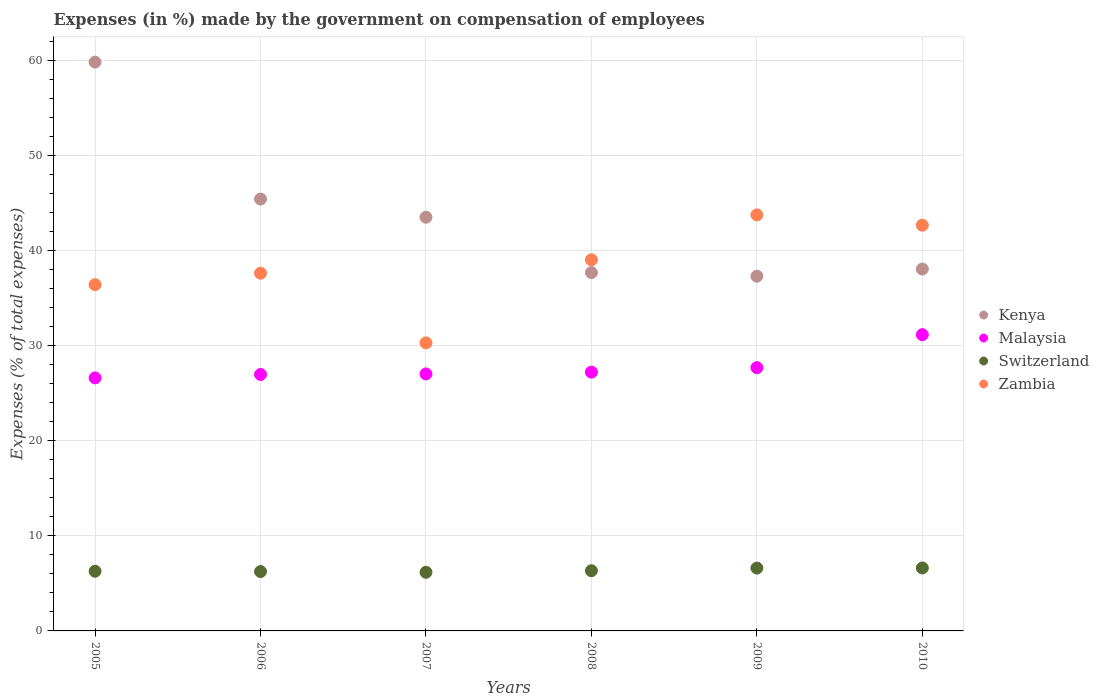Is the number of dotlines equal to the number of legend labels?
Your response must be concise. Yes. What is the percentage of expenses made by the government on compensation of employees in Kenya in 2005?
Give a very brief answer. 59.83. Across all years, what is the maximum percentage of expenses made by the government on compensation of employees in Zambia?
Your answer should be compact. 43.76. Across all years, what is the minimum percentage of expenses made by the government on compensation of employees in Zambia?
Give a very brief answer. 30.3. In which year was the percentage of expenses made by the government on compensation of employees in Kenya maximum?
Your answer should be very brief. 2005. What is the total percentage of expenses made by the government on compensation of employees in Zambia in the graph?
Keep it short and to the point. 229.82. What is the difference between the percentage of expenses made by the government on compensation of employees in Kenya in 2005 and that in 2009?
Keep it short and to the point. 22.52. What is the difference between the percentage of expenses made by the government on compensation of employees in Switzerland in 2006 and the percentage of expenses made by the government on compensation of employees in Zambia in 2007?
Make the answer very short. -24.05. What is the average percentage of expenses made by the government on compensation of employees in Malaysia per year?
Offer a terse response. 27.78. In the year 2006, what is the difference between the percentage of expenses made by the government on compensation of employees in Zambia and percentage of expenses made by the government on compensation of employees in Malaysia?
Keep it short and to the point. 10.66. In how many years, is the percentage of expenses made by the government on compensation of employees in Kenya greater than 22 %?
Ensure brevity in your answer.  6. What is the ratio of the percentage of expenses made by the government on compensation of employees in Switzerland in 2005 to that in 2009?
Offer a terse response. 0.95. Is the percentage of expenses made by the government on compensation of employees in Kenya in 2005 less than that in 2009?
Give a very brief answer. No. What is the difference between the highest and the second highest percentage of expenses made by the government on compensation of employees in Kenya?
Your answer should be compact. 14.41. What is the difference between the highest and the lowest percentage of expenses made by the government on compensation of employees in Zambia?
Offer a terse response. 13.46. In how many years, is the percentage of expenses made by the government on compensation of employees in Switzerland greater than the average percentage of expenses made by the government on compensation of employees in Switzerland taken over all years?
Provide a short and direct response. 2. Is the sum of the percentage of expenses made by the government on compensation of employees in Zambia in 2007 and 2010 greater than the maximum percentage of expenses made by the government on compensation of employees in Kenya across all years?
Ensure brevity in your answer.  Yes. Is it the case that in every year, the sum of the percentage of expenses made by the government on compensation of employees in Malaysia and percentage of expenses made by the government on compensation of employees in Switzerland  is greater than the sum of percentage of expenses made by the government on compensation of employees in Kenya and percentage of expenses made by the government on compensation of employees in Zambia?
Provide a succinct answer. No. Does the percentage of expenses made by the government on compensation of employees in Switzerland monotonically increase over the years?
Provide a succinct answer. No. Is the percentage of expenses made by the government on compensation of employees in Malaysia strictly less than the percentage of expenses made by the government on compensation of employees in Zambia over the years?
Offer a very short reply. Yes. How many years are there in the graph?
Ensure brevity in your answer.  6. Does the graph contain grids?
Ensure brevity in your answer.  Yes. What is the title of the graph?
Provide a succinct answer. Expenses (in %) made by the government on compensation of employees. What is the label or title of the X-axis?
Provide a succinct answer. Years. What is the label or title of the Y-axis?
Your response must be concise. Expenses (% of total expenses). What is the Expenses (% of total expenses) in Kenya in 2005?
Offer a very short reply. 59.83. What is the Expenses (% of total expenses) of Malaysia in 2005?
Offer a very short reply. 26.61. What is the Expenses (% of total expenses) in Switzerland in 2005?
Ensure brevity in your answer.  6.28. What is the Expenses (% of total expenses) in Zambia in 2005?
Offer a terse response. 36.42. What is the Expenses (% of total expenses) of Kenya in 2006?
Make the answer very short. 45.42. What is the Expenses (% of total expenses) of Malaysia in 2006?
Provide a short and direct response. 26.97. What is the Expenses (% of total expenses) in Switzerland in 2006?
Provide a succinct answer. 6.24. What is the Expenses (% of total expenses) in Zambia in 2006?
Give a very brief answer. 37.63. What is the Expenses (% of total expenses) of Kenya in 2007?
Provide a succinct answer. 43.51. What is the Expenses (% of total expenses) of Malaysia in 2007?
Your answer should be compact. 27.03. What is the Expenses (% of total expenses) in Switzerland in 2007?
Make the answer very short. 6.17. What is the Expenses (% of total expenses) in Zambia in 2007?
Give a very brief answer. 30.3. What is the Expenses (% of total expenses) in Kenya in 2008?
Your answer should be very brief. 37.69. What is the Expenses (% of total expenses) of Malaysia in 2008?
Provide a succinct answer. 27.22. What is the Expenses (% of total expenses) in Switzerland in 2008?
Keep it short and to the point. 6.33. What is the Expenses (% of total expenses) in Zambia in 2008?
Ensure brevity in your answer.  39.03. What is the Expenses (% of total expenses) in Kenya in 2009?
Offer a very short reply. 37.31. What is the Expenses (% of total expenses) of Malaysia in 2009?
Ensure brevity in your answer.  27.69. What is the Expenses (% of total expenses) of Switzerland in 2009?
Offer a terse response. 6.61. What is the Expenses (% of total expenses) in Zambia in 2009?
Keep it short and to the point. 43.76. What is the Expenses (% of total expenses) in Kenya in 2010?
Your answer should be compact. 38.07. What is the Expenses (% of total expenses) of Malaysia in 2010?
Provide a short and direct response. 31.16. What is the Expenses (% of total expenses) of Switzerland in 2010?
Your answer should be compact. 6.62. What is the Expenses (% of total expenses) of Zambia in 2010?
Provide a succinct answer. 42.68. Across all years, what is the maximum Expenses (% of total expenses) in Kenya?
Make the answer very short. 59.83. Across all years, what is the maximum Expenses (% of total expenses) of Malaysia?
Provide a short and direct response. 31.16. Across all years, what is the maximum Expenses (% of total expenses) of Switzerland?
Provide a short and direct response. 6.62. Across all years, what is the maximum Expenses (% of total expenses) in Zambia?
Provide a short and direct response. 43.76. Across all years, what is the minimum Expenses (% of total expenses) of Kenya?
Give a very brief answer. 37.31. Across all years, what is the minimum Expenses (% of total expenses) of Malaysia?
Make the answer very short. 26.61. Across all years, what is the minimum Expenses (% of total expenses) of Switzerland?
Offer a very short reply. 6.17. Across all years, what is the minimum Expenses (% of total expenses) in Zambia?
Provide a short and direct response. 30.3. What is the total Expenses (% of total expenses) in Kenya in the graph?
Keep it short and to the point. 261.83. What is the total Expenses (% of total expenses) of Malaysia in the graph?
Offer a very short reply. 166.69. What is the total Expenses (% of total expenses) in Switzerland in the graph?
Your response must be concise. 38.25. What is the total Expenses (% of total expenses) of Zambia in the graph?
Provide a short and direct response. 229.82. What is the difference between the Expenses (% of total expenses) in Kenya in 2005 and that in 2006?
Ensure brevity in your answer.  14.41. What is the difference between the Expenses (% of total expenses) of Malaysia in 2005 and that in 2006?
Your answer should be very brief. -0.36. What is the difference between the Expenses (% of total expenses) of Switzerland in 2005 and that in 2006?
Provide a short and direct response. 0.03. What is the difference between the Expenses (% of total expenses) in Zambia in 2005 and that in 2006?
Ensure brevity in your answer.  -1.21. What is the difference between the Expenses (% of total expenses) of Kenya in 2005 and that in 2007?
Your answer should be compact. 16.32. What is the difference between the Expenses (% of total expenses) in Malaysia in 2005 and that in 2007?
Offer a very short reply. -0.42. What is the difference between the Expenses (% of total expenses) of Switzerland in 2005 and that in 2007?
Offer a very short reply. 0.11. What is the difference between the Expenses (% of total expenses) of Zambia in 2005 and that in 2007?
Provide a short and direct response. 6.12. What is the difference between the Expenses (% of total expenses) in Kenya in 2005 and that in 2008?
Provide a succinct answer. 22.14. What is the difference between the Expenses (% of total expenses) of Malaysia in 2005 and that in 2008?
Provide a short and direct response. -0.61. What is the difference between the Expenses (% of total expenses) in Switzerland in 2005 and that in 2008?
Offer a very short reply. -0.05. What is the difference between the Expenses (% of total expenses) of Zambia in 2005 and that in 2008?
Give a very brief answer. -2.62. What is the difference between the Expenses (% of total expenses) in Kenya in 2005 and that in 2009?
Keep it short and to the point. 22.52. What is the difference between the Expenses (% of total expenses) in Malaysia in 2005 and that in 2009?
Offer a very short reply. -1.08. What is the difference between the Expenses (% of total expenses) of Switzerland in 2005 and that in 2009?
Your response must be concise. -0.33. What is the difference between the Expenses (% of total expenses) of Zambia in 2005 and that in 2009?
Give a very brief answer. -7.34. What is the difference between the Expenses (% of total expenses) in Kenya in 2005 and that in 2010?
Ensure brevity in your answer.  21.77. What is the difference between the Expenses (% of total expenses) in Malaysia in 2005 and that in 2010?
Provide a succinct answer. -4.54. What is the difference between the Expenses (% of total expenses) of Switzerland in 2005 and that in 2010?
Give a very brief answer. -0.34. What is the difference between the Expenses (% of total expenses) of Zambia in 2005 and that in 2010?
Your answer should be compact. -6.26. What is the difference between the Expenses (% of total expenses) of Kenya in 2006 and that in 2007?
Offer a terse response. 1.91. What is the difference between the Expenses (% of total expenses) of Malaysia in 2006 and that in 2007?
Offer a very short reply. -0.06. What is the difference between the Expenses (% of total expenses) in Switzerland in 2006 and that in 2007?
Your response must be concise. 0.08. What is the difference between the Expenses (% of total expenses) of Zambia in 2006 and that in 2007?
Your answer should be very brief. 7.33. What is the difference between the Expenses (% of total expenses) in Kenya in 2006 and that in 2008?
Make the answer very short. 7.73. What is the difference between the Expenses (% of total expenses) in Malaysia in 2006 and that in 2008?
Make the answer very short. -0.25. What is the difference between the Expenses (% of total expenses) of Switzerland in 2006 and that in 2008?
Provide a short and direct response. -0.09. What is the difference between the Expenses (% of total expenses) of Zambia in 2006 and that in 2008?
Give a very brief answer. -1.41. What is the difference between the Expenses (% of total expenses) in Kenya in 2006 and that in 2009?
Make the answer very short. 8.11. What is the difference between the Expenses (% of total expenses) of Malaysia in 2006 and that in 2009?
Your answer should be compact. -0.72. What is the difference between the Expenses (% of total expenses) of Switzerland in 2006 and that in 2009?
Ensure brevity in your answer.  -0.36. What is the difference between the Expenses (% of total expenses) in Zambia in 2006 and that in 2009?
Ensure brevity in your answer.  -6.13. What is the difference between the Expenses (% of total expenses) of Kenya in 2006 and that in 2010?
Your response must be concise. 7.36. What is the difference between the Expenses (% of total expenses) in Malaysia in 2006 and that in 2010?
Ensure brevity in your answer.  -4.19. What is the difference between the Expenses (% of total expenses) of Switzerland in 2006 and that in 2010?
Your answer should be very brief. -0.38. What is the difference between the Expenses (% of total expenses) of Zambia in 2006 and that in 2010?
Give a very brief answer. -5.05. What is the difference between the Expenses (% of total expenses) in Kenya in 2007 and that in 2008?
Ensure brevity in your answer.  5.82. What is the difference between the Expenses (% of total expenses) in Malaysia in 2007 and that in 2008?
Offer a very short reply. -0.19. What is the difference between the Expenses (% of total expenses) of Switzerland in 2007 and that in 2008?
Offer a very short reply. -0.16. What is the difference between the Expenses (% of total expenses) of Zambia in 2007 and that in 2008?
Offer a very short reply. -8.74. What is the difference between the Expenses (% of total expenses) in Kenya in 2007 and that in 2009?
Ensure brevity in your answer.  6.2. What is the difference between the Expenses (% of total expenses) of Malaysia in 2007 and that in 2009?
Ensure brevity in your answer.  -0.66. What is the difference between the Expenses (% of total expenses) of Switzerland in 2007 and that in 2009?
Keep it short and to the point. -0.44. What is the difference between the Expenses (% of total expenses) in Zambia in 2007 and that in 2009?
Your answer should be compact. -13.46. What is the difference between the Expenses (% of total expenses) of Kenya in 2007 and that in 2010?
Your answer should be compact. 5.45. What is the difference between the Expenses (% of total expenses) in Malaysia in 2007 and that in 2010?
Your answer should be very brief. -4.13. What is the difference between the Expenses (% of total expenses) of Switzerland in 2007 and that in 2010?
Provide a succinct answer. -0.46. What is the difference between the Expenses (% of total expenses) of Zambia in 2007 and that in 2010?
Your answer should be compact. -12.38. What is the difference between the Expenses (% of total expenses) of Kenya in 2008 and that in 2009?
Ensure brevity in your answer.  0.38. What is the difference between the Expenses (% of total expenses) in Malaysia in 2008 and that in 2009?
Make the answer very short. -0.47. What is the difference between the Expenses (% of total expenses) of Switzerland in 2008 and that in 2009?
Make the answer very short. -0.28. What is the difference between the Expenses (% of total expenses) in Zambia in 2008 and that in 2009?
Provide a short and direct response. -4.73. What is the difference between the Expenses (% of total expenses) in Kenya in 2008 and that in 2010?
Offer a very short reply. -0.38. What is the difference between the Expenses (% of total expenses) of Malaysia in 2008 and that in 2010?
Provide a short and direct response. -3.94. What is the difference between the Expenses (% of total expenses) in Switzerland in 2008 and that in 2010?
Provide a succinct answer. -0.29. What is the difference between the Expenses (% of total expenses) in Zambia in 2008 and that in 2010?
Make the answer very short. -3.64. What is the difference between the Expenses (% of total expenses) of Kenya in 2009 and that in 2010?
Ensure brevity in your answer.  -0.76. What is the difference between the Expenses (% of total expenses) of Malaysia in 2009 and that in 2010?
Offer a terse response. -3.47. What is the difference between the Expenses (% of total expenses) of Switzerland in 2009 and that in 2010?
Offer a very short reply. -0.01. What is the difference between the Expenses (% of total expenses) of Zambia in 2009 and that in 2010?
Provide a short and direct response. 1.08. What is the difference between the Expenses (% of total expenses) in Kenya in 2005 and the Expenses (% of total expenses) in Malaysia in 2006?
Your response must be concise. 32.86. What is the difference between the Expenses (% of total expenses) of Kenya in 2005 and the Expenses (% of total expenses) of Switzerland in 2006?
Ensure brevity in your answer.  53.59. What is the difference between the Expenses (% of total expenses) of Kenya in 2005 and the Expenses (% of total expenses) of Zambia in 2006?
Give a very brief answer. 22.2. What is the difference between the Expenses (% of total expenses) in Malaysia in 2005 and the Expenses (% of total expenses) in Switzerland in 2006?
Provide a short and direct response. 20.37. What is the difference between the Expenses (% of total expenses) in Malaysia in 2005 and the Expenses (% of total expenses) in Zambia in 2006?
Your answer should be compact. -11.01. What is the difference between the Expenses (% of total expenses) of Switzerland in 2005 and the Expenses (% of total expenses) of Zambia in 2006?
Make the answer very short. -31.35. What is the difference between the Expenses (% of total expenses) in Kenya in 2005 and the Expenses (% of total expenses) in Malaysia in 2007?
Keep it short and to the point. 32.8. What is the difference between the Expenses (% of total expenses) of Kenya in 2005 and the Expenses (% of total expenses) of Switzerland in 2007?
Provide a short and direct response. 53.66. What is the difference between the Expenses (% of total expenses) of Kenya in 2005 and the Expenses (% of total expenses) of Zambia in 2007?
Offer a very short reply. 29.53. What is the difference between the Expenses (% of total expenses) of Malaysia in 2005 and the Expenses (% of total expenses) of Switzerland in 2007?
Offer a terse response. 20.45. What is the difference between the Expenses (% of total expenses) of Malaysia in 2005 and the Expenses (% of total expenses) of Zambia in 2007?
Give a very brief answer. -3.68. What is the difference between the Expenses (% of total expenses) of Switzerland in 2005 and the Expenses (% of total expenses) of Zambia in 2007?
Offer a terse response. -24.02. What is the difference between the Expenses (% of total expenses) of Kenya in 2005 and the Expenses (% of total expenses) of Malaysia in 2008?
Ensure brevity in your answer.  32.61. What is the difference between the Expenses (% of total expenses) of Kenya in 2005 and the Expenses (% of total expenses) of Switzerland in 2008?
Make the answer very short. 53.5. What is the difference between the Expenses (% of total expenses) in Kenya in 2005 and the Expenses (% of total expenses) in Zambia in 2008?
Offer a terse response. 20.8. What is the difference between the Expenses (% of total expenses) in Malaysia in 2005 and the Expenses (% of total expenses) in Switzerland in 2008?
Offer a terse response. 20.28. What is the difference between the Expenses (% of total expenses) of Malaysia in 2005 and the Expenses (% of total expenses) of Zambia in 2008?
Offer a terse response. -12.42. What is the difference between the Expenses (% of total expenses) in Switzerland in 2005 and the Expenses (% of total expenses) in Zambia in 2008?
Keep it short and to the point. -32.76. What is the difference between the Expenses (% of total expenses) of Kenya in 2005 and the Expenses (% of total expenses) of Malaysia in 2009?
Your response must be concise. 32.14. What is the difference between the Expenses (% of total expenses) in Kenya in 2005 and the Expenses (% of total expenses) in Switzerland in 2009?
Your response must be concise. 53.22. What is the difference between the Expenses (% of total expenses) in Kenya in 2005 and the Expenses (% of total expenses) in Zambia in 2009?
Give a very brief answer. 16.07. What is the difference between the Expenses (% of total expenses) of Malaysia in 2005 and the Expenses (% of total expenses) of Switzerland in 2009?
Your response must be concise. 20. What is the difference between the Expenses (% of total expenses) of Malaysia in 2005 and the Expenses (% of total expenses) of Zambia in 2009?
Provide a succinct answer. -17.15. What is the difference between the Expenses (% of total expenses) in Switzerland in 2005 and the Expenses (% of total expenses) in Zambia in 2009?
Your answer should be compact. -37.48. What is the difference between the Expenses (% of total expenses) of Kenya in 2005 and the Expenses (% of total expenses) of Malaysia in 2010?
Provide a succinct answer. 28.67. What is the difference between the Expenses (% of total expenses) of Kenya in 2005 and the Expenses (% of total expenses) of Switzerland in 2010?
Your answer should be very brief. 53.21. What is the difference between the Expenses (% of total expenses) of Kenya in 2005 and the Expenses (% of total expenses) of Zambia in 2010?
Keep it short and to the point. 17.16. What is the difference between the Expenses (% of total expenses) of Malaysia in 2005 and the Expenses (% of total expenses) of Switzerland in 2010?
Provide a succinct answer. 19.99. What is the difference between the Expenses (% of total expenses) of Malaysia in 2005 and the Expenses (% of total expenses) of Zambia in 2010?
Offer a terse response. -16.06. What is the difference between the Expenses (% of total expenses) in Switzerland in 2005 and the Expenses (% of total expenses) in Zambia in 2010?
Keep it short and to the point. -36.4. What is the difference between the Expenses (% of total expenses) in Kenya in 2006 and the Expenses (% of total expenses) in Malaysia in 2007?
Offer a very short reply. 18.39. What is the difference between the Expenses (% of total expenses) of Kenya in 2006 and the Expenses (% of total expenses) of Switzerland in 2007?
Keep it short and to the point. 39.26. What is the difference between the Expenses (% of total expenses) of Kenya in 2006 and the Expenses (% of total expenses) of Zambia in 2007?
Ensure brevity in your answer.  15.12. What is the difference between the Expenses (% of total expenses) in Malaysia in 2006 and the Expenses (% of total expenses) in Switzerland in 2007?
Make the answer very short. 20.81. What is the difference between the Expenses (% of total expenses) in Malaysia in 2006 and the Expenses (% of total expenses) in Zambia in 2007?
Keep it short and to the point. -3.33. What is the difference between the Expenses (% of total expenses) of Switzerland in 2006 and the Expenses (% of total expenses) of Zambia in 2007?
Keep it short and to the point. -24.05. What is the difference between the Expenses (% of total expenses) of Kenya in 2006 and the Expenses (% of total expenses) of Malaysia in 2008?
Offer a very short reply. 18.2. What is the difference between the Expenses (% of total expenses) of Kenya in 2006 and the Expenses (% of total expenses) of Switzerland in 2008?
Make the answer very short. 39.09. What is the difference between the Expenses (% of total expenses) in Kenya in 2006 and the Expenses (% of total expenses) in Zambia in 2008?
Provide a short and direct response. 6.39. What is the difference between the Expenses (% of total expenses) in Malaysia in 2006 and the Expenses (% of total expenses) in Switzerland in 2008?
Provide a short and direct response. 20.64. What is the difference between the Expenses (% of total expenses) in Malaysia in 2006 and the Expenses (% of total expenses) in Zambia in 2008?
Keep it short and to the point. -12.06. What is the difference between the Expenses (% of total expenses) in Switzerland in 2006 and the Expenses (% of total expenses) in Zambia in 2008?
Keep it short and to the point. -32.79. What is the difference between the Expenses (% of total expenses) of Kenya in 2006 and the Expenses (% of total expenses) of Malaysia in 2009?
Provide a succinct answer. 17.73. What is the difference between the Expenses (% of total expenses) in Kenya in 2006 and the Expenses (% of total expenses) in Switzerland in 2009?
Offer a very short reply. 38.81. What is the difference between the Expenses (% of total expenses) of Kenya in 2006 and the Expenses (% of total expenses) of Zambia in 2009?
Make the answer very short. 1.66. What is the difference between the Expenses (% of total expenses) in Malaysia in 2006 and the Expenses (% of total expenses) in Switzerland in 2009?
Your response must be concise. 20.36. What is the difference between the Expenses (% of total expenses) of Malaysia in 2006 and the Expenses (% of total expenses) of Zambia in 2009?
Provide a succinct answer. -16.79. What is the difference between the Expenses (% of total expenses) in Switzerland in 2006 and the Expenses (% of total expenses) in Zambia in 2009?
Provide a short and direct response. -37.52. What is the difference between the Expenses (% of total expenses) of Kenya in 2006 and the Expenses (% of total expenses) of Malaysia in 2010?
Offer a terse response. 14.27. What is the difference between the Expenses (% of total expenses) in Kenya in 2006 and the Expenses (% of total expenses) in Switzerland in 2010?
Your answer should be compact. 38.8. What is the difference between the Expenses (% of total expenses) of Kenya in 2006 and the Expenses (% of total expenses) of Zambia in 2010?
Offer a very short reply. 2.75. What is the difference between the Expenses (% of total expenses) in Malaysia in 2006 and the Expenses (% of total expenses) in Switzerland in 2010?
Your response must be concise. 20.35. What is the difference between the Expenses (% of total expenses) of Malaysia in 2006 and the Expenses (% of total expenses) of Zambia in 2010?
Your answer should be compact. -15.7. What is the difference between the Expenses (% of total expenses) of Switzerland in 2006 and the Expenses (% of total expenses) of Zambia in 2010?
Ensure brevity in your answer.  -36.43. What is the difference between the Expenses (% of total expenses) in Kenya in 2007 and the Expenses (% of total expenses) in Malaysia in 2008?
Your answer should be very brief. 16.29. What is the difference between the Expenses (% of total expenses) of Kenya in 2007 and the Expenses (% of total expenses) of Switzerland in 2008?
Provide a short and direct response. 37.18. What is the difference between the Expenses (% of total expenses) in Kenya in 2007 and the Expenses (% of total expenses) in Zambia in 2008?
Ensure brevity in your answer.  4.48. What is the difference between the Expenses (% of total expenses) of Malaysia in 2007 and the Expenses (% of total expenses) of Switzerland in 2008?
Offer a terse response. 20.7. What is the difference between the Expenses (% of total expenses) of Malaysia in 2007 and the Expenses (% of total expenses) of Zambia in 2008?
Your response must be concise. -12. What is the difference between the Expenses (% of total expenses) of Switzerland in 2007 and the Expenses (% of total expenses) of Zambia in 2008?
Your response must be concise. -32.87. What is the difference between the Expenses (% of total expenses) in Kenya in 2007 and the Expenses (% of total expenses) in Malaysia in 2009?
Your answer should be very brief. 15.82. What is the difference between the Expenses (% of total expenses) in Kenya in 2007 and the Expenses (% of total expenses) in Switzerland in 2009?
Offer a terse response. 36.9. What is the difference between the Expenses (% of total expenses) in Kenya in 2007 and the Expenses (% of total expenses) in Zambia in 2009?
Your answer should be very brief. -0.25. What is the difference between the Expenses (% of total expenses) of Malaysia in 2007 and the Expenses (% of total expenses) of Switzerland in 2009?
Your response must be concise. 20.42. What is the difference between the Expenses (% of total expenses) of Malaysia in 2007 and the Expenses (% of total expenses) of Zambia in 2009?
Make the answer very short. -16.73. What is the difference between the Expenses (% of total expenses) in Switzerland in 2007 and the Expenses (% of total expenses) in Zambia in 2009?
Your answer should be very brief. -37.59. What is the difference between the Expenses (% of total expenses) in Kenya in 2007 and the Expenses (% of total expenses) in Malaysia in 2010?
Make the answer very short. 12.35. What is the difference between the Expenses (% of total expenses) of Kenya in 2007 and the Expenses (% of total expenses) of Switzerland in 2010?
Give a very brief answer. 36.89. What is the difference between the Expenses (% of total expenses) in Kenya in 2007 and the Expenses (% of total expenses) in Zambia in 2010?
Your answer should be compact. 0.84. What is the difference between the Expenses (% of total expenses) in Malaysia in 2007 and the Expenses (% of total expenses) in Switzerland in 2010?
Provide a succinct answer. 20.41. What is the difference between the Expenses (% of total expenses) in Malaysia in 2007 and the Expenses (% of total expenses) in Zambia in 2010?
Give a very brief answer. -15.64. What is the difference between the Expenses (% of total expenses) in Switzerland in 2007 and the Expenses (% of total expenses) in Zambia in 2010?
Your answer should be compact. -36.51. What is the difference between the Expenses (% of total expenses) in Kenya in 2008 and the Expenses (% of total expenses) in Malaysia in 2009?
Make the answer very short. 10. What is the difference between the Expenses (% of total expenses) of Kenya in 2008 and the Expenses (% of total expenses) of Switzerland in 2009?
Your response must be concise. 31.08. What is the difference between the Expenses (% of total expenses) in Kenya in 2008 and the Expenses (% of total expenses) in Zambia in 2009?
Ensure brevity in your answer.  -6.07. What is the difference between the Expenses (% of total expenses) of Malaysia in 2008 and the Expenses (% of total expenses) of Switzerland in 2009?
Ensure brevity in your answer.  20.61. What is the difference between the Expenses (% of total expenses) of Malaysia in 2008 and the Expenses (% of total expenses) of Zambia in 2009?
Your answer should be very brief. -16.54. What is the difference between the Expenses (% of total expenses) of Switzerland in 2008 and the Expenses (% of total expenses) of Zambia in 2009?
Ensure brevity in your answer.  -37.43. What is the difference between the Expenses (% of total expenses) in Kenya in 2008 and the Expenses (% of total expenses) in Malaysia in 2010?
Ensure brevity in your answer.  6.53. What is the difference between the Expenses (% of total expenses) in Kenya in 2008 and the Expenses (% of total expenses) in Switzerland in 2010?
Provide a succinct answer. 31.07. What is the difference between the Expenses (% of total expenses) in Kenya in 2008 and the Expenses (% of total expenses) in Zambia in 2010?
Offer a very short reply. -4.99. What is the difference between the Expenses (% of total expenses) in Malaysia in 2008 and the Expenses (% of total expenses) in Switzerland in 2010?
Make the answer very short. 20.6. What is the difference between the Expenses (% of total expenses) in Malaysia in 2008 and the Expenses (% of total expenses) in Zambia in 2010?
Your response must be concise. -15.46. What is the difference between the Expenses (% of total expenses) of Switzerland in 2008 and the Expenses (% of total expenses) of Zambia in 2010?
Keep it short and to the point. -36.35. What is the difference between the Expenses (% of total expenses) of Kenya in 2009 and the Expenses (% of total expenses) of Malaysia in 2010?
Provide a succinct answer. 6.15. What is the difference between the Expenses (% of total expenses) of Kenya in 2009 and the Expenses (% of total expenses) of Switzerland in 2010?
Give a very brief answer. 30.69. What is the difference between the Expenses (% of total expenses) of Kenya in 2009 and the Expenses (% of total expenses) of Zambia in 2010?
Your response must be concise. -5.37. What is the difference between the Expenses (% of total expenses) of Malaysia in 2009 and the Expenses (% of total expenses) of Switzerland in 2010?
Ensure brevity in your answer.  21.07. What is the difference between the Expenses (% of total expenses) in Malaysia in 2009 and the Expenses (% of total expenses) in Zambia in 2010?
Provide a succinct answer. -14.99. What is the difference between the Expenses (% of total expenses) of Switzerland in 2009 and the Expenses (% of total expenses) of Zambia in 2010?
Provide a short and direct response. -36.07. What is the average Expenses (% of total expenses) in Kenya per year?
Give a very brief answer. 43.64. What is the average Expenses (% of total expenses) of Malaysia per year?
Ensure brevity in your answer.  27.78. What is the average Expenses (% of total expenses) of Switzerland per year?
Provide a succinct answer. 6.38. What is the average Expenses (% of total expenses) in Zambia per year?
Your answer should be very brief. 38.3. In the year 2005, what is the difference between the Expenses (% of total expenses) of Kenya and Expenses (% of total expenses) of Malaysia?
Keep it short and to the point. 33.22. In the year 2005, what is the difference between the Expenses (% of total expenses) in Kenya and Expenses (% of total expenses) in Switzerland?
Offer a terse response. 53.55. In the year 2005, what is the difference between the Expenses (% of total expenses) of Kenya and Expenses (% of total expenses) of Zambia?
Provide a succinct answer. 23.41. In the year 2005, what is the difference between the Expenses (% of total expenses) in Malaysia and Expenses (% of total expenses) in Switzerland?
Offer a very short reply. 20.34. In the year 2005, what is the difference between the Expenses (% of total expenses) in Malaysia and Expenses (% of total expenses) in Zambia?
Offer a very short reply. -9.8. In the year 2005, what is the difference between the Expenses (% of total expenses) in Switzerland and Expenses (% of total expenses) in Zambia?
Your response must be concise. -30.14. In the year 2006, what is the difference between the Expenses (% of total expenses) in Kenya and Expenses (% of total expenses) in Malaysia?
Your answer should be very brief. 18.45. In the year 2006, what is the difference between the Expenses (% of total expenses) in Kenya and Expenses (% of total expenses) in Switzerland?
Provide a succinct answer. 39.18. In the year 2006, what is the difference between the Expenses (% of total expenses) of Kenya and Expenses (% of total expenses) of Zambia?
Your answer should be compact. 7.79. In the year 2006, what is the difference between the Expenses (% of total expenses) in Malaysia and Expenses (% of total expenses) in Switzerland?
Offer a very short reply. 20.73. In the year 2006, what is the difference between the Expenses (% of total expenses) of Malaysia and Expenses (% of total expenses) of Zambia?
Your response must be concise. -10.66. In the year 2006, what is the difference between the Expenses (% of total expenses) in Switzerland and Expenses (% of total expenses) in Zambia?
Your answer should be very brief. -31.38. In the year 2007, what is the difference between the Expenses (% of total expenses) in Kenya and Expenses (% of total expenses) in Malaysia?
Ensure brevity in your answer.  16.48. In the year 2007, what is the difference between the Expenses (% of total expenses) of Kenya and Expenses (% of total expenses) of Switzerland?
Offer a terse response. 37.34. In the year 2007, what is the difference between the Expenses (% of total expenses) of Kenya and Expenses (% of total expenses) of Zambia?
Provide a short and direct response. 13.21. In the year 2007, what is the difference between the Expenses (% of total expenses) in Malaysia and Expenses (% of total expenses) in Switzerland?
Offer a very short reply. 20.87. In the year 2007, what is the difference between the Expenses (% of total expenses) of Malaysia and Expenses (% of total expenses) of Zambia?
Offer a very short reply. -3.27. In the year 2007, what is the difference between the Expenses (% of total expenses) of Switzerland and Expenses (% of total expenses) of Zambia?
Your response must be concise. -24.13. In the year 2008, what is the difference between the Expenses (% of total expenses) in Kenya and Expenses (% of total expenses) in Malaysia?
Provide a succinct answer. 10.47. In the year 2008, what is the difference between the Expenses (% of total expenses) in Kenya and Expenses (% of total expenses) in Switzerland?
Make the answer very short. 31.36. In the year 2008, what is the difference between the Expenses (% of total expenses) of Kenya and Expenses (% of total expenses) of Zambia?
Provide a short and direct response. -1.35. In the year 2008, what is the difference between the Expenses (% of total expenses) of Malaysia and Expenses (% of total expenses) of Switzerland?
Give a very brief answer. 20.89. In the year 2008, what is the difference between the Expenses (% of total expenses) in Malaysia and Expenses (% of total expenses) in Zambia?
Ensure brevity in your answer.  -11.81. In the year 2008, what is the difference between the Expenses (% of total expenses) of Switzerland and Expenses (% of total expenses) of Zambia?
Give a very brief answer. -32.7. In the year 2009, what is the difference between the Expenses (% of total expenses) of Kenya and Expenses (% of total expenses) of Malaysia?
Give a very brief answer. 9.62. In the year 2009, what is the difference between the Expenses (% of total expenses) in Kenya and Expenses (% of total expenses) in Switzerland?
Offer a terse response. 30.7. In the year 2009, what is the difference between the Expenses (% of total expenses) of Kenya and Expenses (% of total expenses) of Zambia?
Keep it short and to the point. -6.45. In the year 2009, what is the difference between the Expenses (% of total expenses) in Malaysia and Expenses (% of total expenses) in Switzerland?
Make the answer very short. 21.08. In the year 2009, what is the difference between the Expenses (% of total expenses) of Malaysia and Expenses (% of total expenses) of Zambia?
Your answer should be very brief. -16.07. In the year 2009, what is the difference between the Expenses (% of total expenses) in Switzerland and Expenses (% of total expenses) in Zambia?
Your answer should be very brief. -37.15. In the year 2010, what is the difference between the Expenses (% of total expenses) in Kenya and Expenses (% of total expenses) in Malaysia?
Provide a short and direct response. 6.91. In the year 2010, what is the difference between the Expenses (% of total expenses) of Kenya and Expenses (% of total expenses) of Switzerland?
Offer a terse response. 31.44. In the year 2010, what is the difference between the Expenses (% of total expenses) in Kenya and Expenses (% of total expenses) in Zambia?
Your response must be concise. -4.61. In the year 2010, what is the difference between the Expenses (% of total expenses) of Malaysia and Expenses (% of total expenses) of Switzerland?
Your answer should be compact. 24.53. In the year 2010, what is the difference between the Expenses (% of total expenses) in Malaysia and Expenses (% of total expenses) in Zambia?
Offer a terse response. -11.52. In the year 2010, what is the difference between the Expenses (% of total expenses) in Switzerland and Expenses (% of total expenses) in Zambia?
Provide a short and direct response. -36.05. What is the ratio of the Expenses (% of total expenses) of Kenya in 2005 to that in 2006?
Offer a very short reply. 1.32. What is the ratio of the Expenses (% of total expenses) in Malaysia in 2005 to that in 2006?
Ensure brevity in your answer.  0.99. What is the ratio of the Expenses (% of total expenses) of Switzerland in 2005 to that in 2006?
Give a very brief answer. 1.01. What is the ratio of the Expenses (% of total expenses) in Zambia in 2005 to that in 2006?
Your answer should be very brief. 0.97. What is the ratio of the Expenses (% of total expenses) in Kenya in 2005 to that in 2007?
Provide a short and direct response. 1.38. What is the ratio of the Expenses (% of total expenses) in Malaysia in 2005 to that in 2007?
Make the answer very short. 0.98. What is the ratio of the Expenses (% of total expenses) in Switzerland in 2005 to that in 2007?
Your answer should be very brief. 1.02. What is the ratio of the Expenses (% of total expenses) of Zambia in 2005 to that in 2007?
Offer a terse response. 1.2. What is the ratio of the Expenses (% of total expenses) of Kenya in 2005 to that in 2008?
Your answer should be very brief. 1.59. What is the ratio of the Expenses (% of total expenses) of Malaysia in 2005 to that in 2008?
Ensure brevity in your answer.  0.98. What is the ratio of the Expenses (% of total expenses) in Zambia in 2005 to that in 2008?
Keep it short and to the point. 0.93. What is the ratio of the Expenses (% of total expenses) of Kenya in 2005 to that in 2009?
Provide a succinct answer. 1.6. What is the ratio of the Expenses (% of total expenses) of Malaysia in 2005 to that in 2009?
Provide a succinct answer. 0.96. What is the ratio of the Expenses (% of total expenses) of Switzerland in 2005 to that in 2009?
Give a very brief answer. 0.95. What is the ratio of the Expenses (% of total expenses) in Zambia in 2005 to that in 2009?
Provide a succinct answer. 0.83. What is the ratio of the Expenses (% of total expenses) of Kenya in 2005 to that in 2010?
Give a very brief answer. 1.57. What is the ratio of the Expenses (% of total expenses) of Malaysia in 2005 to that in 2010?
Make the answer very short. 0.85. What is the ratio of the Expenses (% of total expenses) in Switzerland in 2005 to that in 2010?
Your response must be concise. 0.95. What is the ratio of the Expenses (% of total expenses) of Zambia in 2005 to that in 2010?
Give a very brief answer. 0.85. What is the ratio of the Expenses (% of total expenses) of Kenya in 2006 to that in 2007?
Give a very brief answer. 1.04. What is the ratio of the Expenses (% of total expenses) in Malaysia in 2006 to that in 2007?
Your answer should be compact. 1. What is the ratio of the Expenses (% of total expenses) of Switzerland in 2006 to that in 2007?
Offer a terse response. 1.01. What is the ratio of the Expenses (% of total expenses) of Zambia in 2006 to that in 2007?
Provide a short and direct response. 1.24. What is the ratio of the Expenses (% of total expenses) in Kenya in 2006 to that in 2008?
Offer a terse response. 1.21. What is the ratio of the Expenses (% of total expenses) of Malaysia in 2006 to that in 2008?
Provide a short and direct response. 0.99. What is the ratio of the Expenses (% of total expenses) of Switzerland in 2006 to that in 2008?
Provide a short and direct response. 0.99. What is the ratio of the Expenses (% of total expenses) of Kenya in 2006 to that in 2009?
Ensure brevity in your answer.  1.22. What is the ratio of the Expenses (% of total expenses) in Malaysia in 2006 to that in 2009?
Provide a short and direct response. 0.97. What is the ratio of the Expenses (% of total expenses) in Switzerland in 2006 to that in 2009?
Offer a very short reply. 0.94. What is the ratio of the Expenses (% of total expenses) of Zambia in 2006 to that in 2009?
Ensure brevity in your answer.  0.86. What is the ratio of the Expenses (% of total expenses) of Kenya in 2006 to that in 2010?
Your answer should be very brief. 1.19. What is the ratio of the Expenses (% of total expenses) in Malaysia in 2006 to that in 2010?
Ensure brevity in your answer.  0.87. What is the ratio of the Expenses (% of total expenses) of Switzerland in 2006 to that in 2010?
Your answer should be very brief. 0.94. What is the ratio of the Expenses (% of total expenses) in Zambia in 2006 to that in 2010?
Make the answer very short. 0.88. What is the ratio of the Expenses (% of total expenses) of Kenya in 2007 to that in 2008?
Keep it short and to the point. 1.15. What is the ratio of the Expenses (% of total expenses) of Malaysia in 2007 to that in 2008?
Provide a short and direct response. 0.99. What is the ratio of the Expenses (% of total expenses) in Switzerland in 2007 to that in 2008?
Provide a short and direct response. 0.97. What is the ratio of the Expenses (% of total expenses) in Zambia in 2007 to that in 2008?
Provide a succinct answer. 0.78. What is the ratio of the Expenses (% of total expenses) in Kenya in 2007 to that in 2009?
Provide a short and direct response. 1.17. What is the ratio of the Expenses (% of total expenses) in Malaysia in 2007 to that in 2009?
Give a very brief answer. 0.98. What is the ratio of the Expenses (% of total expenses) of Switzerland in 2007 to that in 2009?
Provide a short and direct response. 0.93. What is the ratio of the Expenses (% of total expenses) in Zambia in 2007 to that in 2009?
Your answer should be compact. 0.69. What is the ratio of the Expenses (% of total expenses) in Kenya in 2007 to that in 2010?
Offer a terse response. 1.14. What is the ratio of the Expenses (% of total expenses) in Malaysia in 2007 to that in 2010?
Provide a succinct answer. 0.87. What is the ratio of the Expenses (% of total expenses) in Switzerland in 2007 to that in 2010?
Offer a terse response. 0.93. What is the ratio of the Expenses (% of total expenses) of Zambia in 2007 to that in 2010?
Offer a very short reply. 0.71. What is the ratio of the Expenses (% of total expenses) in Kenya in 2008 to that in 2009?
Ensure brevity in your answer.  1.01. What is the ratio of the Expenses (% of total expenses) of Switzerland in 2008 to that in 2009?
Your response must be concise. 0.96. What is the ratio of the Expenses (% of total expenses) of Zambia in 2008 to that in 2009?
Provide a succinct answer. 0.89. What is the ratio of the Expenses (% of total expenses) in Malaysia in 2008 to that in 2010?
Your answer should be very brief. 0.87. What is the ratio of the Expenses (% of total expenses) in Switzerland in 2008 to that in 2010?
Your answer should be compact. 0.96. What is the ratio of the Expenses (% of total expenses) of Zambia in 2008 to that in 2010?
Provide a short and direct response. 0.91. What is the ratio of the Expenses (% of total expenses) of Kenya in 2009 to that in 2010?
Your answer should be compact. 0.98. What is the ratio of the Expenses (% of total expenses) in Malaysia in 2009 to that in 2010?
Your response must be concise. 0.89. What is the ratio of the Expenses (% of total expenses) in Switzerland in 2009 to that in 2010?
Provide a short and direct response. 1. What is the ratio of the Expenses (% of total expenses) of Zambia in 2009 to that in 2010?
Offer a terse response. 1.03. What is the difference between the highest and the second highest Expenses (% of total expenses) of Kenya?
Offer a very short reply. 14.41. What is the difference between the highest and the second highest Expenses (% of total expenses) of Malaysia?
Your answer should be compact. 3.47. What is the difference between the highest and the second highest Expenses (% of total expenses) in Switzerland?
Offer a very short reply. 0.01. What is the difference between the highest and the second highest Expenses (% of total expenses) of Zambia?
Offer a terse response. 1.08. What is the difference between the highest and the lowest Expenses (% of total expenses) of Kenya?
Your answer should be compact. 22.52. What is the difference between the highest and the lowest Expenses (% of total expenses) of Malaysia?
Your answer should be very brief. 4.54. What is the difference between the highest and the lowest Expenses (% of total expenses) of Switzerland?
Offer a very short reply. 0.46. What is the difference between the highest and the lowest Expenses (% of total expenses) in Zambia?
Your answer should be very brief. 13.46. 